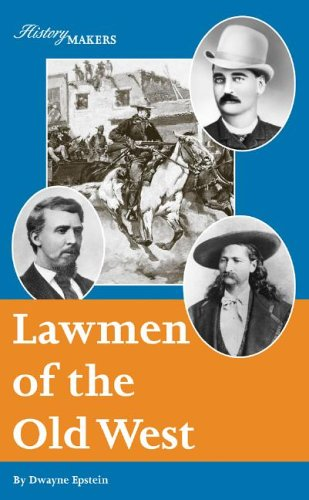Who wrote this book? The book 'Lawmen of the Old West' was authored by Dwayne Epstein, who delves into historical narratives to explore the lives and times of notable historical figures. 